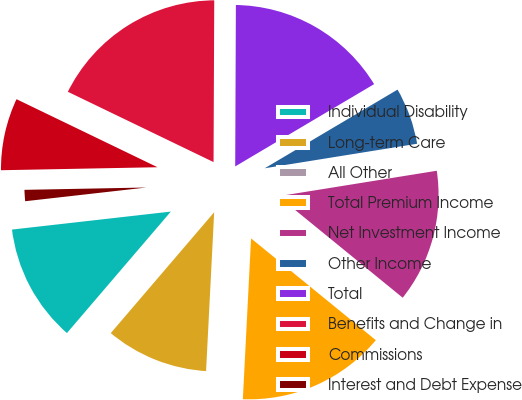Convert chart. <chart><loc_0><loc_0><loc_500><loc_500><pie_chart><fcel>Individual Disability<fcel>Long-term Care<fcel>All Other<fcel>Total Premium Income<fcel>Net Investment Income<fcel>Other Income<fcel>Total<fcel>Benefits and Change in<fcel>Commissions<fcel>Interest and Debt Expense<nl><fcel>11.94%<fcel>10.45%<fcel>0.0%<fcel>14.92%<fcel>13.43%<fcel>5.97%<fcel>16.42%<fcel>17.91%<fcel>7.46%<fcel>1.49%<nl></chart> 